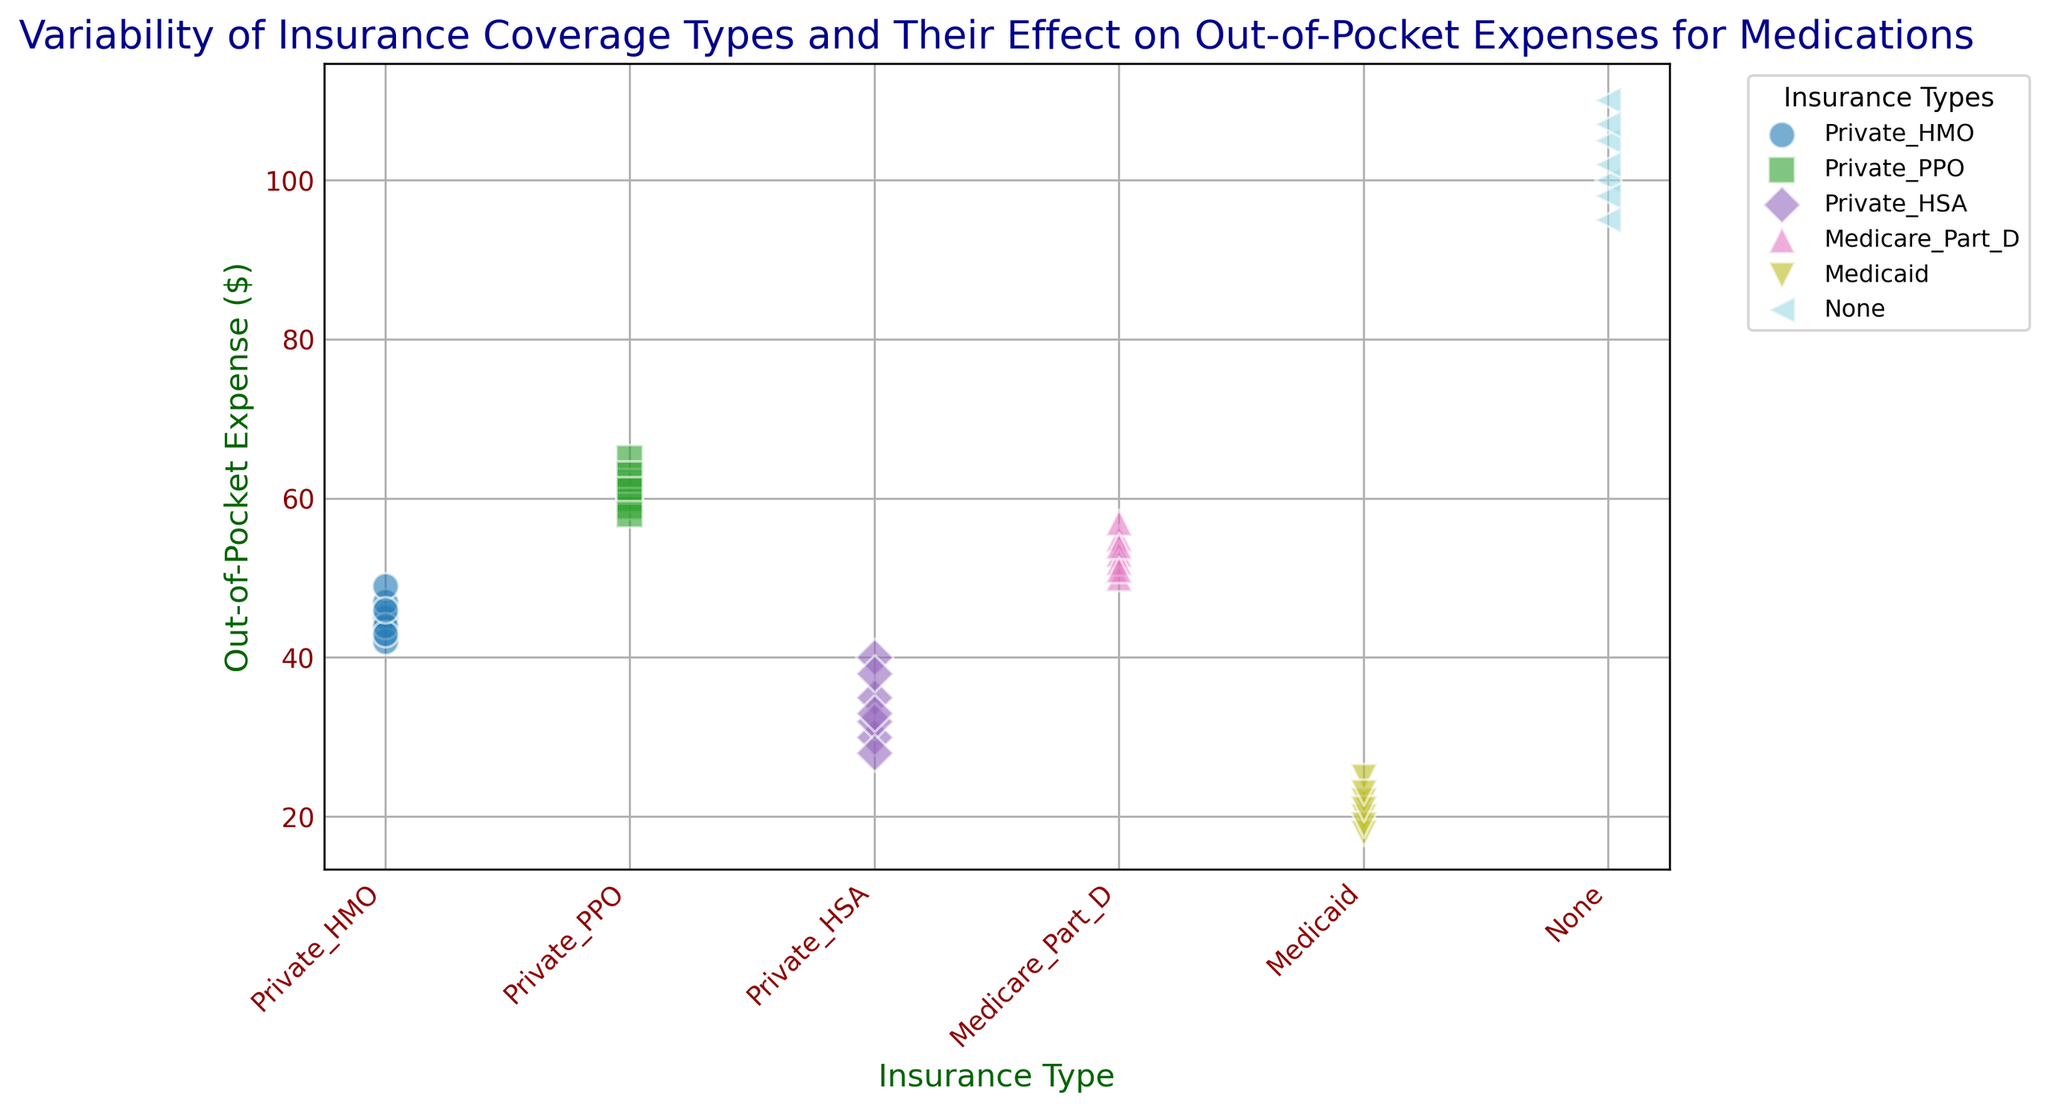What is the range of out-of-pocket expenses for Medicaid? To find the range, look at the highest and lowest points of the Medicaid cluster. The highest expense is $25, and the lowest expense is $18. The range is $25 - $18.
Answer: $7 Which insurance type has the highest average out-of-pocket expense? Calculate the average for each insurance type by summing their expenses and dividing by the number of data points. None has the highest average because its values (100, 105, 98, 110, 95, 102, 107) sum up to 717, and dividing by 7 gives an average of 102.43.
Answer: None How does the median out-of-pocket expense for Private HSA compare to Medicare Part D? Calculate the median for both. Private HSA values (35, 30, 40, 32, 28, 38, 33) have a median of 33. Medicare Part D values (55, 53, 57, 50, 52, 54, 51) have a median of 53.
Answer: Medicare Part D's median is higher Which insurance type shows the greatest variability in out-of-pocket expenses? Variability is visualized as the spread of points. None has points spread widely from 95 to 110. Private HSA, in contrast, has tighter grouping.
Answer: None Is there any insurance type that consistently has low out-of-pocket expenses? Look for clusters that are consistently at the lower end of the y-axis. Medicaid shows consistently low expenses (18, 19, 20, 21, 22, 23, 25).
Answer: Medicaid Compare the highest out-of-pocket expense for Private PPO and Private HMO. Identify the highest values in each cluster. Private PPO's highest expense is $65, and Private HMO's highest expense is $49.
Answer: Private PPO’s highest expense is higher Determine the total out-of-pocket expense for all Private HMO cases? Sum all the columns of Private HMO. The expenses are 45, 42, 47, 44, 49, 43, 46. Summing yields 316.
Answer: $316 How do the out-of-pocket expenses for Private PPO compare to Medicare Part D? Evaluate the spread and overlapping of clusters visually. Private PPO expenses range higher (58-65), while Medicare Part D ranges slightly lower (50-57).
Answer: Private PPO has higher expenses Which insurance type has the lowest minimum out-of-pocket expense? Visually identify the lowest point for each cluster. Medicaid has the minimum lowest value of $18.
Answer: Medicaid 